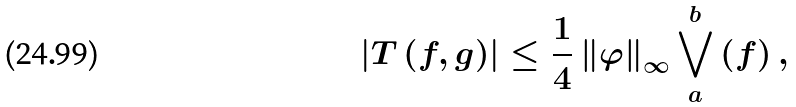<formula> <loc_0><loc_0><loc_500><loc_500>\left | T \left ( f , g \right ) \right | \leq \frac { 1 } { 4 } \left \| \varphi \right \| _ { \infty } \bigvee _ { a } ^ { b } \left ( f \right ) ,</formula> 